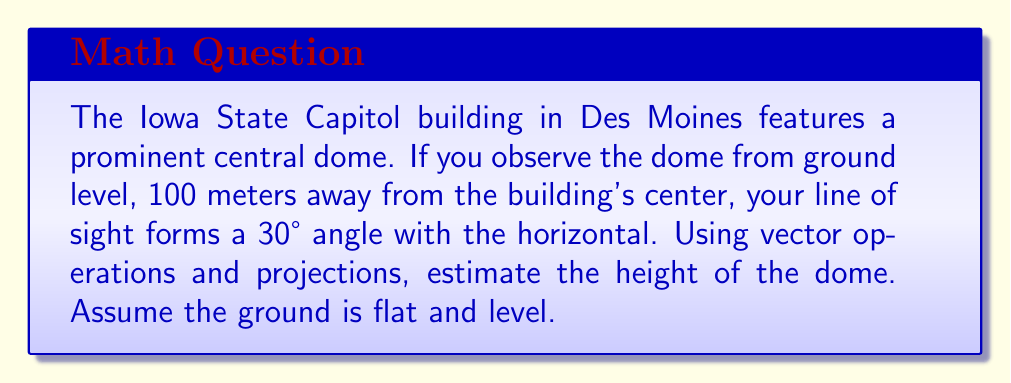Could you help me with this problem? Let's approach this step-by-step using vector operations and projections:

1) First, let's define our vectors:
   - Let $\vec{v}$ be the vector from the observer to the top of the dome
   - Let $\vec{h}$ be the horizontal vector from the observer to the base of the dome

2) We know that $|\vec{h}| = 100$ meters (the distance from the observer to the building's center)

3) The angle between $\vec{v}$ and $\vec{h}$ is 30°

4) We can represent $\vec{v}$ as the sum of $\vec{h}$ and a vertical vector $\vec{y}$:
   
   $\vec{v} = \vec{h} + \vec{y}$

5) The projection of $\vec{v}$ onto $\vec{h}$ is $\vec{h}$ itself:
   
   $\text{proj}_{\vec{h}}\vec{v} = \vec{h}$

6) The magnitude of this projection is related to the magnitude of $\vec{v}$ by the cosine of the angle:
   
   $|\text{proj}_{\vec{h}}\vec{v}| = |\vec{v}| \cos(30°)$

7) We can write:
   
   $100 = |\vec{v}| \cos(30°)$

8) Solving for $|\vec{v}|$:
   
   $|\vec{v}| = \frac{100}{\cos(30°)} \approx 115.47$ meters

9) Now, the height of the dome is the vertical component of $\vec{v}$, which is $|\vec{v}| \sin(30°)$:
   
   $\text{height} = 115.47 \sin(30°) \approx 57.74$ meters

Therefore, the estimated height of the Iowa State Capitol dome is approximately 57.74 meters.
Answer: 57.74 meters 